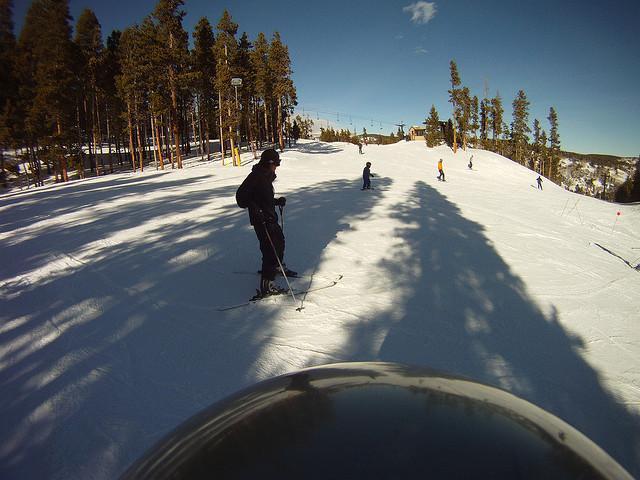What surrounds these people?
Answer the question by selecting the correct answer among the 4 following choices.
Options: Sand, mud, ocean, mountains. Mountains. 